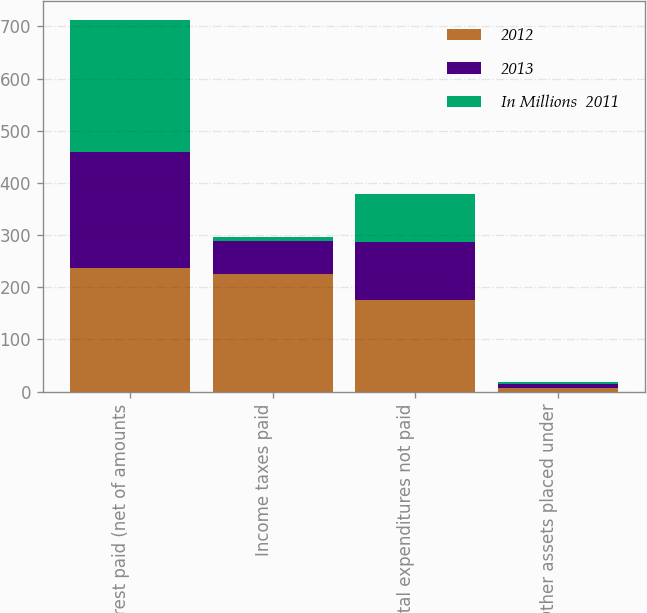Convert chart. <chart><loc_0><loc_0><loc_500><loc_500><stacked_bar_chart><ecel><fcel>Interest paid (net of amounts<fcel>Income taxes paid<fcel>Capital expenditures not paid<fcel>Other assets placed under<nl><fcel>2012<fcel>236<fcel>225<fcel>176<fcel>6<nl><fcel>2013<fcel>224<fcel>63<fcel>110<fcel>9<nl><fcel>In Millions  2011<fcel>253<fcel>8<fcel>92<fcel>4<nl></chart> 